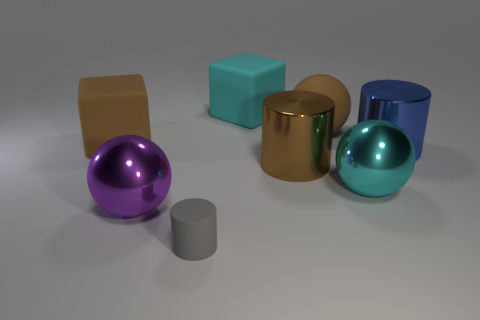Subtract all large brown balls. How many balls are left? 2 Subtract 1 spheres. How many spheres are left? 2 Add 2 small balls. How many objects exist? 10 Subtract all cyan cylinders. Subtract all purple spheres. How many cylinders are left? 3 Subtract all cubes. How many objects are left? 6 Subtract all gray rubber balls. Subtract all small things. How many objects are left? 7 Add 7 blue metal cylinders. How many blue metal cylinders are left? 8 Add 4 metallic spheres. How many metallic spheres exist? 6 Subtract 1 purple balls. How many objects are left? 7 